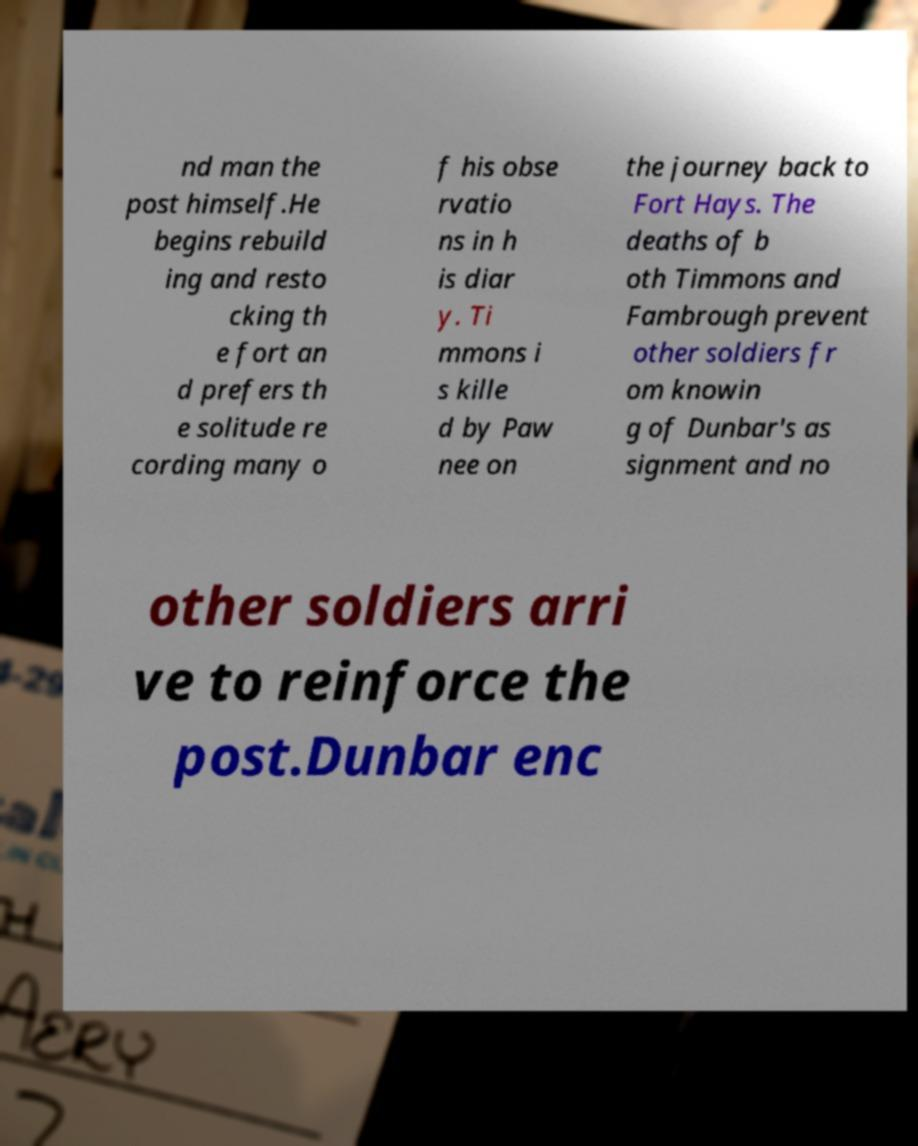I need the written content from this picture converted into text. Can you do that? nd man the post himself.He begins rebuild ing and resto cking th e fort an d prefers th e solitude re cording many o f his obse rvatio ns in h is diar y. Ti mmons i s kille d by Paw nee on the journey back to Fort Hays. The deaths of b oth Timmons and Fambrough prevent other soldiers fr om knowin g of Dunbar's as signment and no other soldiers arri ve to reinforce the post.Dunbar enc 